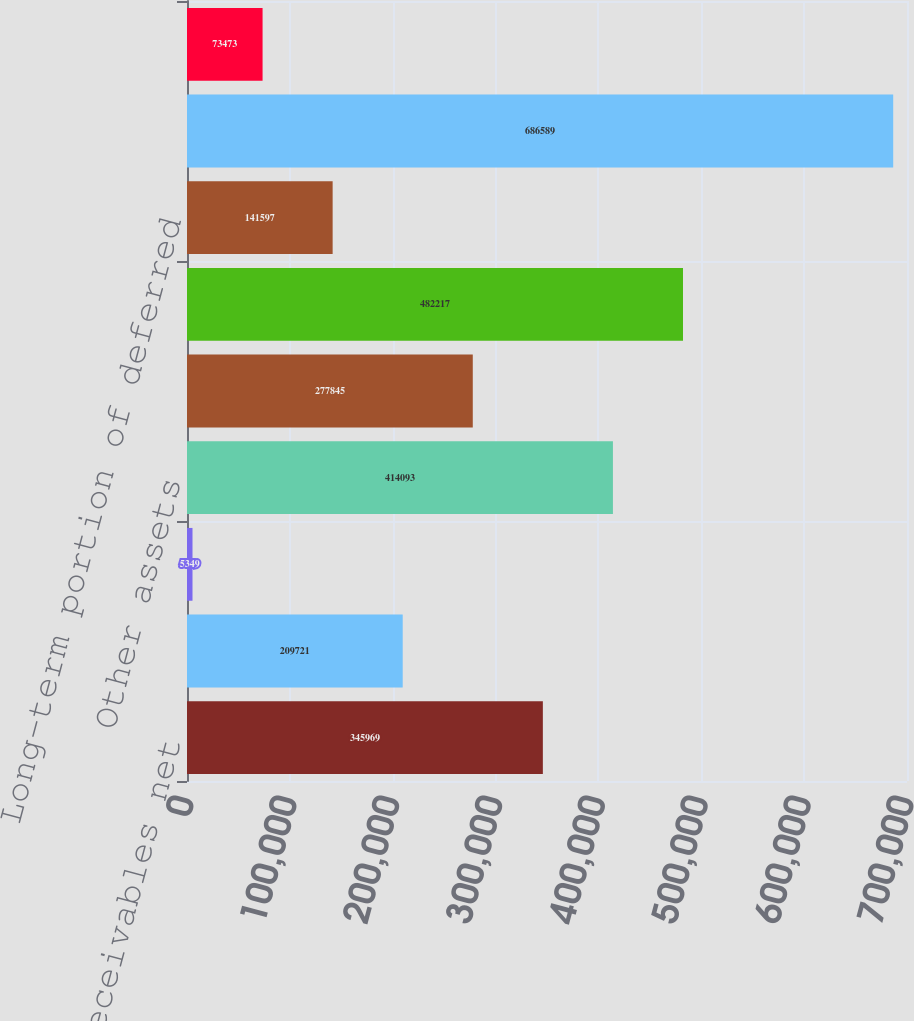Convert chart. <chart><loc_0><loc_0><loc_500><loc_500><bar_chart><fcel>Receivables net<fcel>Prepaid expenses and other<fcel>Long-term receivables<fcel>Other assets<fcel>Accounts payable and accrued<fcel>Current portion of deferred<fcel>Long-term portion of deferred<fcel>Retained earnings<fcel>Accumulated other<nl><fcel>345969<fcel>209721<fcel>5349<fcel>414093<fcel>277845<fcel>482217<fcel>141597<fcel>686589<fcel>73473<nl></chart> 